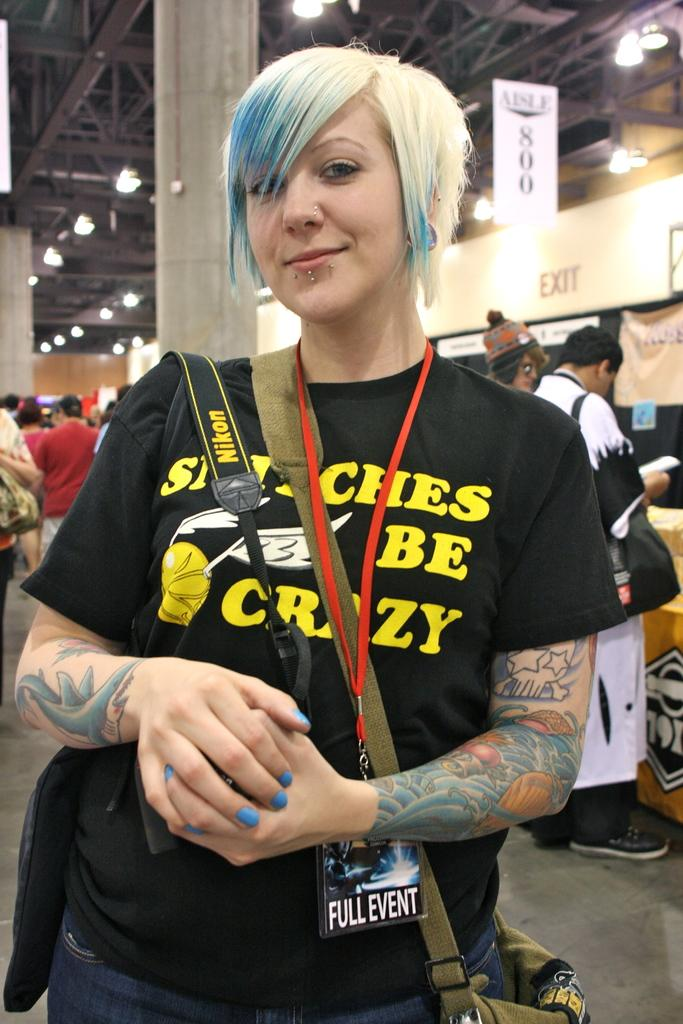Who is present in the image? There is a woman in the image. What is the woman wearing? The woman is wearing a bag. Where is the woman standing? The woman is standing on the floor. What can be seen above the woman in the image? There is a roof visible in the image, and there are ceiling lights on the roof. What architectural feature is present in the image? There is a pillar in the image. Are there any other people in the image besides the woman? Yes, there are people standing in the image. What type of fuel is being used by the tank in the image? There is no tank present in the image, so it is not possible to determine what type of fuel is being used. 